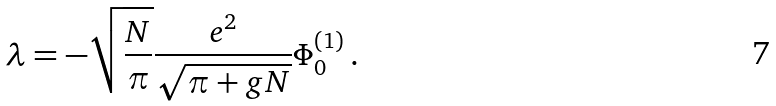Convert formula to latex. <formula><loc_0><loc_0><loc_500><loc_500>\lambda = - \sqrt { \frac { N } { \pi } } \frac { e ^ { 2 } } { \sqrt { \pi + g N } } \Phi _ { 0 } ^ { ( 1 ) } \, .</formula> 